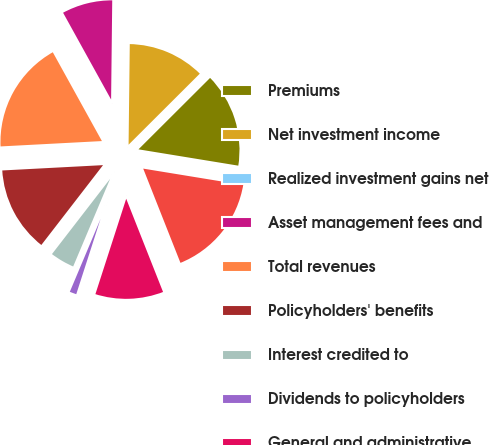Convert chart to OTSL. <chart><loc_0><loc_0><loc_500><loc_500><pie_chart><fcel>Premiums<fcel>Net investment income<fcel>Realized investment gains net<fcel>Asset management fees and<fcel>Total revenues<fcel>Policyholders' benefits<fcel>Interest credited to<fcel>Dividends to policyholders<fcel>General and administrative<fcel>Total benefits and expenses<nl><fcel>15.06%<fcel>12.33%<fcel>0.01%<fcel>8.22%<fcel>17.8%<fcel>13.69%<fcel>4.12%<fcel>1.38%<fcel>10.96%<fcel>16.43%<nl></chart> 